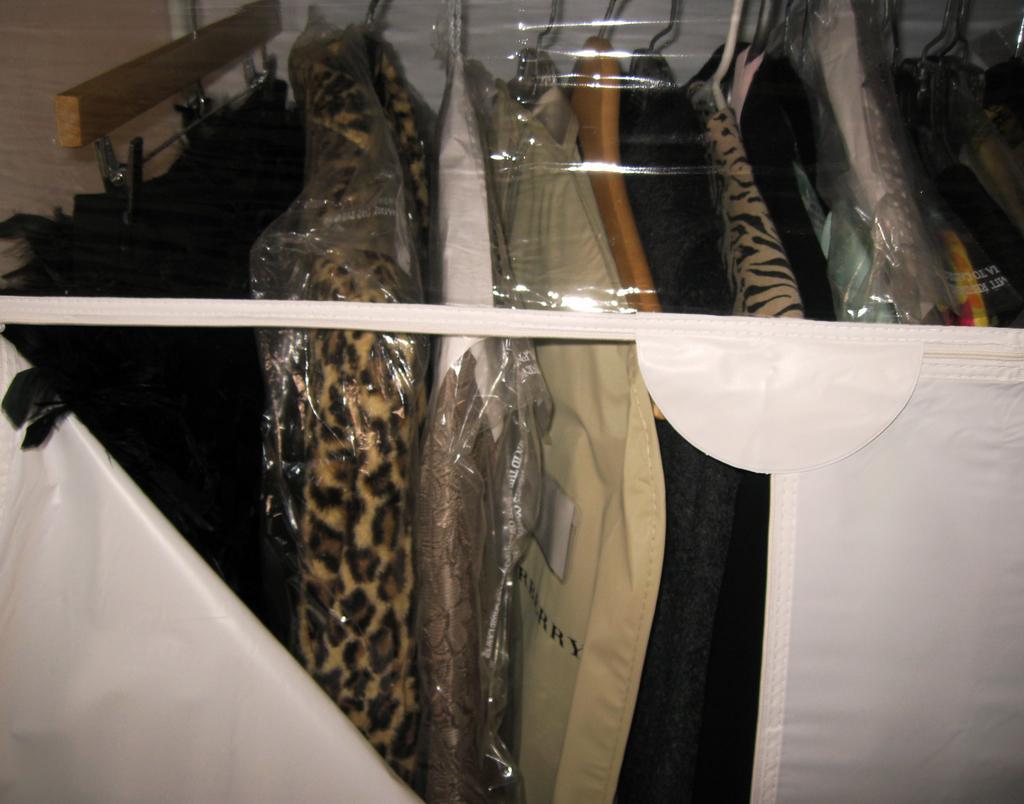Can you describe this image briefly? In this image there are suits hanged in a cupboard. 